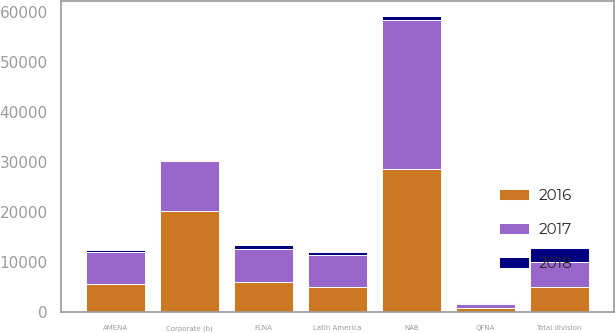Convert chart to OTSL. <chart><loc_0><loc_0><loc_500><loc_500><stacked_bar_chart><ecel><fcel>FLNA<fcel>QFNA<fcel>NAB<fcel>Latin America<fcel>AMENA<fcel>Total division<fcel>Corporate (b)<nl><fcel>2017<fcel>6577<fcel>870<fcel>29878<fcel>6458<fcel>6433<fcel>4976<fcel>10022<nl><fcel>2016<fcel>5979<fcel>804<fcel>28592<fcel>4976<fcel>5668<fcel>4976<fcel>20229<nl><fcel>2018<fcel>801<fcel>41<fcel>769<fcel>507<fcel>381<fcel>2938<fcel>102<nl></chart> 